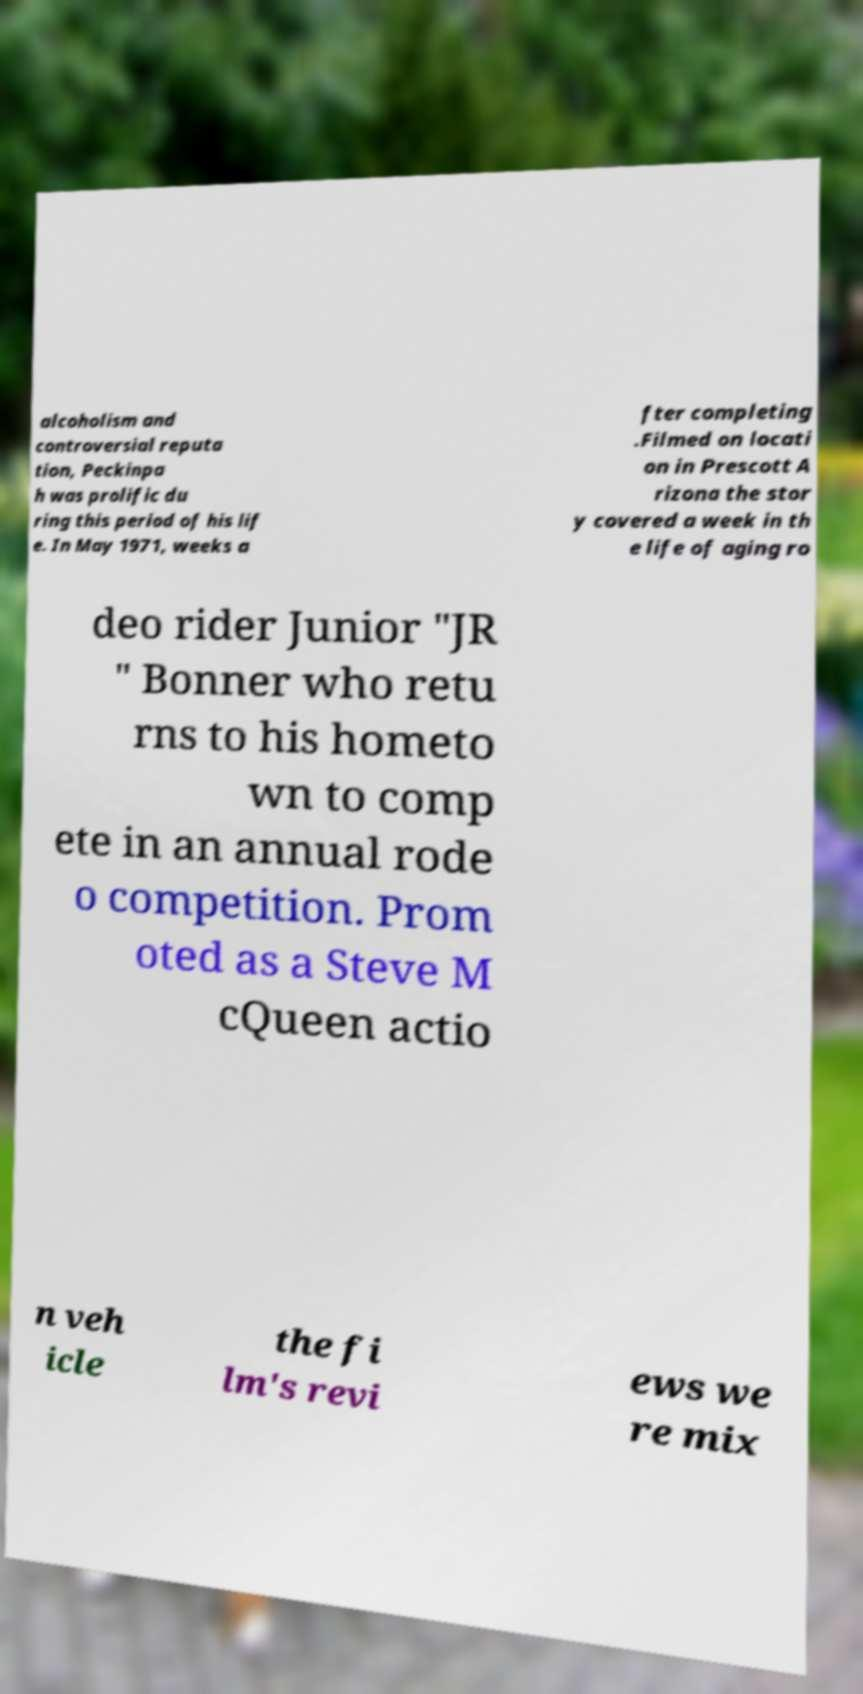Can you read and provide the text displayed in the image?This photo seems to have some interesting text. Can you extract and type it out for me? alcoholism and controversial reputa tion, Peckinpa h was prolific du ring this period of his lif e. In May 1971, weeks a fter completing .Filmed on locati on in Prescott A rizona the stor y covered a week in th e life of aging ro deo rider Junior "JR " Bonner who retu rns to his hometo wn to comp ete in an annual rode o competition. Prom oted as a Steve M cQueen actio n veh icle the fi lm's revi ews we re mix 